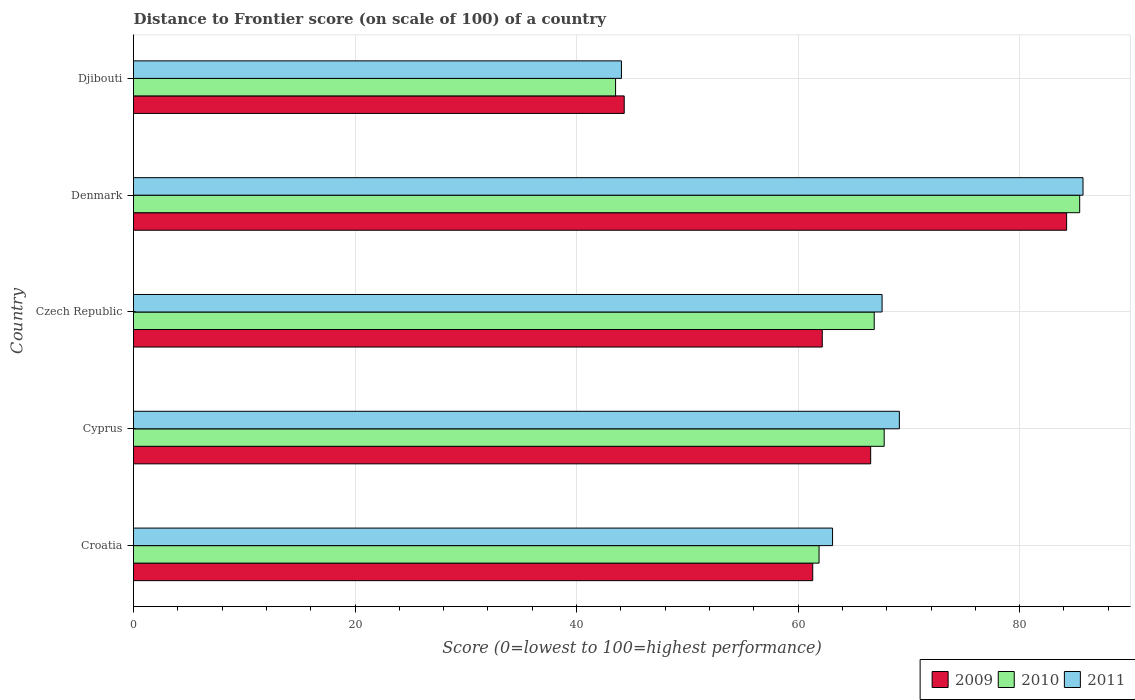How many different coloured bars are there?
Provide a short and direct response. 3. Are the number of bars on each tick of the Y-axis equal?
Your answer should be very brief. Yes. How many bars are there on the 5th tick from the top?
Offer a very short reply. 3. How many bars are there on the 1st tick from the bottom?
Give a very brief answer. 3. What is the label of the 3rd group of bars from the top?
Your response must be concise. Czech Republic. In how many cases, is the number of bars for a given country not equal to the number of legend labels?
Your answer should be compact. 0. What is the distance to frontier score of in 2010 in Czech Republic?
Your answer should be very brief. 66.87. Across all countries, what is the maximum distance to frontier score of in 2011?
Your answer should be compact. 85.72. Across all countries, what is the minimum distance to frontier score of in 2011?
Your answer should be very brief. 44.05. In which country was the distance to frontier score of in 2011 minimum?
Offer a very short reply. Djibouti. What is the total distance to frontier score of in 2011 in the graph?
Your answer should be compact. 329.6. What is the difference between the distance to frontier score of in 2009 in Croatia and that in Denmark?
Keep it short and to the point. -22.92. What is the difference between the distance to frontier score of in 2010 in Djibouti and the distance to frontier score of in 2009 in Cyprus?
Your answer should be compact. -23.03. What is the average distance to frontier score of in 2009 per country?
Offer a very short reply. 63.72. What is the difference between the distance to frontier score of in 2010 and distance to frontier score of in 2009 in Denmark?
Provide a succinct answer. 1.18. In how many countries, is the distance to frontier score of in 2010 greater than 84 ?
Make the answer very short. 1. What is the ratio of the distance to frontier score of in 2009 in Croatia to that in Djibouti?
Ensure brevity in your answer.  1.38. Is the difference between the distance to frontier score of in 2010 in Czech Republic and Djibouti greater than the difference between the distance to frontier score of in 2009 in Czech Republic and Djibouti?
Provide a short and direct response. Yes. What is the difference between the highest and the second highest distance to frontier score of in 2009?
Provide a short and direct response. 17.69. What is the difference between the highest and the lowest distance to frontier score of in 2009?
Give a very brief answer. 39.94. In how many countries, is the distance to frontier score of in 2010 greater than the average distance to frontier score of in 2010 taken over all countries?
Keep it short and to the point. 3. Is the sum of the distance to frontier score of in 2010 in Cyprus and Djibouti greater than the maximum distance to frontier score of in 2011 across all countries?
Your answer should be very brief. Yes. How many bars are there?
Your answer should be very brief. 15. Are all the bars in the graph horizontal?
Make the answer very short. Yes. Are the values on the major ticks of X-axis written in scientific E-notation?
Your response must be concise. No. Does the graph contain grids?
Your response must be concise. Yes. How are the legend labels stacked?
Offer a very short reply. Horizontal. What is the title of the graph?
Your answer should be compact. Distance to Frontier score (on scale of 100) of a country. What is the label or title of the X-axis?
Provide a succinct answer. Score (0=lowest to 100=highest performance). What is the Score (0=lowest to 100=highest performance) in 2009 in Croatia?
Make the answer very short. 61.32. What is the Score (0=lowest to 100=highest performance) in 2010 in Croatia?
Provide a succinct answer. 61.89. What is the Score (0=lowest to 100=highest performance) in 2011 in Croatia?
Provide a short and direct response. 63.11. What is the Score (0=lowest to 100=highest performance) in 2009 in Cyprus?
Your response must be concise. 66.55. What is the Score (0=lowest to 100=highest performance) of 2010 in Cyprus?
Provide a succinct answer. 67.77. What is the Score (0=lowest to 100=highest performance) of 2011 in Cyprus?
Keep it short and to the point. 69.14. What is the Score (0=lowest to 100=highest performance) in 2009 in Czech Republic?
Your response must be concise. 62.18. What is the Score (0=lowest to 100=highest performance) in 2010 in Czech Republic?
Keep it short and to the point. 66.87. What is the Score (0=lowest to 100=highest performance) of 2011 in Czech Republic?
Your answer should be compact. 67.58. What is the Score (0=lowest to 100=highest performance) of 2009 in Denmark?
Offer a very short reply. 84.24. What is the Score (0=lowest to 100=highest performance) in 2010 in Denmark?
Your response must be concise. 85.42. What is the Score (0=lowest to 100=highest performance) in 2011 in Denmark?
Keep it short and to the point. 85.72. What is the Score (0=lowest to 100=highest performance) in 2009 in Djibouti?
Provide a succinct answer. 44.3. What is the Score (0=lowest to 100=highest performance) in 2010 in Djibouti?
Your answer should be very brief. 43.52. What is the Score (0=lowest to 100=highest performance) of 2011 in Djibouti?
Make the answer very short. 44.05. Across all countries, what is the maximum Score (0=lowest to 100=highest performance) of 2009?
Your answer should be compact. 84.24. Across all countries, what is the maximum Score (0=lowest to 100=highest performance) of 2010?
Offer a terse response. 85.42. Across all countries, what is the maximum Score (0=lowest to 100=highest performance) of 2011?
Ensure brevity in your answer.  85.72. Across all countries, what is the minimum Score (0=lowest to 100=highest performance) in 2009?
Your response must be concise. 44.3. Across all countries, what is the minimum Score (0=lowest to 100=highest performance) in 2010?
Provide a succinct answer. 43.52. Across all countries, what is the minimum Score (0=lowest to 100=highest performance) in 2011?
Ensure brevity in your answer.  44.05. What is the total Score (0=lowest to 100=highest performance) of 2009 in the graph?
Keep it short and to the point. 318.59. What is the total Score (0=lowest to 100=highest performance) in 2010 in the graph?
Your response must be concise. 325.47. What is the total Score (0=lowest to 100=highest performance) of 2011 in the graph?
Provide a succinct answer. 329.6. What is the difference between the Score (0=lowest to 100=highest performance) of 2009 in Croatia and that in Cyprus?
Provide a short and direct response. -5.23. What is the difference between the Score (0=lowest to 100=highest performance) of 2010 in Croatia and that in Cyprus?
Your response must be concise. -5.88. What is the difference between the Score (0=lowest to 100=highest performance) of 2011 in Croatia and that in Cyprus?
Your response must be concise. -6.03. What is the difference between the Score (0=lowest to 100=highest performance) in 2009 in Croatia and that in Czech Republic?
Give a very brief answer. -0.86. What is the difference between the Score (0=lowest to 100=highest performance) of 2010 in Croatia and that in Czech Republic?
Make the answer very short. -4.98. What is the difference between the Score (0=lowest to 100=highest performance) in 2011 in Croatia and that in Czech Republic?
Give a very brief answer. -4.47. What is the difference between the Score (0=lowest to 100=highest performance) in 2009 in Croatia and that in Denmark?
Keep it short and to the point. -22.92. What is the difference between the Score (0=lowest to 100=highest performance) of 2010 in Croatia and that in Denmark?
Make the answer very short. -23.53. What is the difference between the Score (0=lowest to 100=highest performance) in 2011 in Croatia and that in Denmark?
Make the answer very short. -22.61. What is the difference between the Score (0=lowest to 100=highest performance) of 2009 in Croatia and that in Djibouti?
Offer a terse response. 17.02. What is the difference between the Score (0=lowest to 100=highest performance) of 2010 in Croatia and that in Djibouti?
Give a very brief answer. 18.37. What is the difference between the Score (0=lowest to 100=highest performance) in 2011 in Croatia and that in Djibouti?
Your answer should be compact. 19.06. What is the difference between the Score (0=lowest to 100=highest performance) in 2009 in Cyprus and that in Czech Republic?
Keep it short and to the point. 4.37. What is the difference between the Score (0=lowest to 100=highest performance) in 2010 in Cyprus and that in Czech Republic?
Your response must be concise. 0.9. What is the difference between the Score (0=lowest to 100=highest performance) of 2011 in Cyprus and that in Czech Republic?
Make the answer very short. 1.56. What is the difference between the Score (0=lowest to 100=highest performance) of 2009 in Cyprus and that in Denmark?
Ensure brevity in your answer.  -17.69. What is the difference between the Score (0=lowest to 100=highest performance) of 2010 in Cyprus and that in Denmark?
Offer a very short reply. -17.65. What is the difference between the Score (0=lowest to 100=highest performance) of 2011 in Cyprus and that in Denmark?
Keep it short and to the point. -16.58. What is the difference between the Score (0=lowest to 100=highest performance) of 2009 in Cyprus and that in Djibouti?
Your answer should be compact. 22.25. What is the difference between the Score (0=lowest to 100=highest performance) of 2010 in Cyprus and that in Djibouti?
Provide a short and direct response. 24.25. What is the difference between the Score (0=lowest to 100=highest performance) of 2011 in Cyprus and that in Djibouti?
Ensure brevity in your answer.  25.09. What is the difference between the Score (0=lowest to 100=highest performance) in 2009 in Czech Republic and that in Denmark?
Your answer should be compact. -22.06. What is the difference between the Score (0=lowest to 100=highest performance) of 2010 in Czech Republic and that in Denmark?
Keep it short and to the point. -18.55. What is the difference between the Score (0=lowest to 100=highest performance) in 2011 in Czech Republic and that in Denmark?
Keep it short and to the point. -18.14. What is the difference between the Score (0=lowest to 100=highest performance) of 2009 in Czech Republic and that in Djibouti?
Your answer should be very brief. 17.88. What is the difference between the Score (0=lowest to 100=highest performance) in 2010 in Czech Republic and that in Djibouti?
Provide a succinct answer. 23.35. What is the difference between the Score (0=lowest to 100=highest performance) in 2011 in Czech Republic and that in Djibouti?
Your answer should be compact. 23.53. What is the difference between the Score (0=lowest to 100=highest performance) of 2009 in Denmark and that in Djibouti?
Provide a short and direct response. 39.94. What is the difference between the Score (0=lowest to 100=highest performance) of 2010 in Denmark and that in Djibouti?
Offer a very short reply. 41.9. What is the difference between the Score (0=lowest to 100=highest performance) in 2011 in Denmark and that in Djibouti?
Provide a succinct answer. 41.67. What is the difference between the Score (0=lowest to 100=highest performance) in 2009 in Croatia and the Score (0=lowest to 100=highest performance) in 2010 in Cyprus?
Offer a terse response. -6.45. What is the difference between the Score (0=lowest to 100=highest performance) of 2009 in Croatia and the Score (0=lowest to 100=highest performance) of 2011 in Cyprus?
Give a very brief answer. -7.82. What is the difference between the Score (0=lowest to 100=highest performance) in 2010 in Croatia and the Score (0=lowest to 100=highest performance) in 2011 in Cyprus?
Give a very brief answer. -7.25. What is the difference between the Score (0=lowest to 100=highest performance) in 2009 in Croatia and the Score (0=lowest to 100=highest performance) in 2010 in Czech Republic?
Provide a succinct answer. -5.55. What is the difference between the Score (0=lowest to 100=highest performance) in 2009 in Croatia and the Score (0=lowest to 100=highest performance) in 2011 in Czech Republic?
Your answer should be compact. -6.26. What is the difference between the Score (0=lowest to 100=highest performance) in 2010 in Croatia and the Score (0=lowest to 100=highest performance) in 2011 in Czech Republic?
Provide a short and direct response. -5.69. What is the difference between the Score (0=lowest to 100=highest performance) in 2009 in Croatia and the Score (0=lowest to 100=highest performance) in 2010 in Denmark?
Keep it short and to the point. -24.1. What is the difference between the Score (0=lowest to 100=highest performance) of 2009 in Croatia and the Score (0=lowest to 100=highest performance) of 2011 in Denmark?
Offer a terse response. -24.4. What is the difference between the Score (0=lowest to 100=highest performance) in 2010 in Croatia and the Score (0=lowest to 100=highest performance) in 2011 in Denmark?
Your answer should be compact. -23.83. What is the difference between the Score (0=lowest to 100=highest performance) in 2009 in Croatia and the Score (0=lowest to 100=highest performance) in 2011 in Djibouti?
Provide a short and direct response. 17.27. What is the difference between the Score (0=lowest to 100=highest performance) in 2010 in Croatia and the Score (0=lowest to 100=highest performance) in 2011 in Djibouti?
Provide a succinct answer. 17.84. What is the difference between the Score (0=lowest to 100=highest performance) of 2009 in Cyprus and the Score (0=lowest to 100=highest performance) of 2010 in Czech Republic?
Provide a succinct answer. -0.32. What is the difference between the Score (0=lowest to 100=highest performance) of 2009 in Cyprus and the Score (0=lowest to 100=highest performance) of 2011 in Czech Republic?
Offer a terse response. -1.03. What is the difference between the Score (0=lowest to 100=highest performance) in 2010 in Cyprus and the Score (0=lowest to 100=highest performance) in 2011 in Czech Republic?
Keep it short and to the point. 0.19. What is the difference between the Score (0=lowest to 100=highest performance) of 2009 in Cyprus and the Score (0=lowest to 100=highest performance) of 2010 in Denmark?
Keep it short and to the point. -18.87. What is the difference between the Score (0=lowest to 100=highest performance) in 2009 in Cyprus and the Score (0=lowest to 100=highest performance) in 2011 in Denmark?
Make the answer very short. -19.17. What is the difference between the Score (0=lowest to 100=highest performance) of 2010 in Cyprus and the Score (0=lowest to 100=highest performance) of 2011 in Denmark?
Your answer should be very brief. -17.95. What is the difference between the Score (0=lowest to 100=highest performance) of 2009 in Cyprus and the Score (0=lowest to 100=highest performance) of 2010 in Djibouti?
Give a very brief answer. 23.03. What is the difference between the Score (0=lowest to 100=highest performance) in 2010 in Cyprus and the Score (0=lowest to 100=highest performance) in 2011 in Djibouti?
Keep it short and to the point. 23.72. What is the difference between the Score (0=lowest to 100=highest performance) in 2009 in Czech Republic and the Score (0=lowest to 100=highest performance) in 2010 in Denmark?
Your answer should be compact. -23.24. What is the difference between the Score (0=lowest to 100=highest performance) of 2009 in Czech Republic and the Score (0=lowest to 100=highest performance) of 2011 in Denmark?
Provide a succinct answer. -23.54. What is the difference between the Score (0=lowest to 100=highest performance) of 2010 in Czech Republic and the Score (0=lowest to 100=highest performance) of 2011 in Denmark?
Keep it short and to the point. -18.85. What is the difference between the Score (0=lowest to 100=highest performance) of 2009 in Czech Republic and the Score (0=lowest to 100=highest performance) of 2010 in Djibouti?
Provide a short and direct response. 18.66. What is the difference between the Score (0=lowest to 100=highest performance) of 2009 in Czech Republic and the Score (0=lowest to 100=highest performance) of 2011 in Djibouti?
Provide a succinct answer. 18.13. What is the difference between the Score (0=lowest to 100=highest performance) of 2010 in Czech Republic and the Score (0=lowest to 100=highest performance) of 2011 in Djibouti?
Offer a very short reply. 22.82. What is the difference between the Score (0=lowest to 100=highest performance) of 2009 in Denmark and the Score (0=lowest to 100=highest performance) of 2010 in Djibouti?
Keep it short and to the point. 40.72. What is the difference between the Score (0=lowest to 100=highest performance) of 2009 in Denmark and the Score (0=lowest to 100=highest performance) of 2011 in Djibouti?
Give a very brief answer. 40.19. What is the difference between the Score (0=lowest to 100=highest performance) of 2010 in Denmark and the Score (0=lowest to 100=highest performance) of 2011 in Djibouti?
Provide a succinct answer. 41.37. What is the average Score (0=lowest to 100=highest performance) of 2009 per country?
Provide a short and direct response. 63.72. What is the average Score (0=lowest to 100=highest performance) of 2010 per country?
Your response must be concise. 65.09. What is the average Score (0=lowest to 100=highest performance) of 2011 per country?
Offer a very short reply. 65.92. What is the difference between the Score (0=lowest to 100=highest performance) of 2009 and Score (0=lowest to 100=highest performance) of 2010 in Croatia?
Provide a succinct answer. -0.57. What is the difference between the Score (0=lowest to 100=highest performance) of 2009 and Score (0=lowest to 100=highest performance) of 2011 in Croatia?
Your answer should be compact. -1.79. What is the difference between the Score (0=lowest to 100=highest performance) in 2010 and Score (0=lowest to 100=highest performance) in 2011 in Croatia?
Provide a succinct answer. -1.22. What is the difference between the Score (0=lowest to 100=highest performance) in 2009 and Score (0=lowest to 100=highest performance) in 2010 in Cyprus?
Your answer should be very brief. -1.22. What is the difference between the Score (0=lowest to 100=highest performance) in 2009 and Score (0=lowest to 100=highest performance) in 2011 in Cyprus?
Provide a short and direct response. -2.59. What is the difference between the Score (0=lowest to 100=highest performance) in 2010 and Score (0=lowest to 100=highest performance) in 2011 in Cyprus?
Provide a short and direct response. -1.37. What is the difference between the Score (0=lowest to 100=highest performance) of 2009 and Score (0=lowest to 100=highest performance) of 2010 in Czech Republic?
Offer a very short reply. -4.69. What is the difference between the Score (0=lowest to 100=highest performance) of 2010 and Score (0=lowest to 100=highest performance) of 2011 in Czech Republic?
Your answer should be compact. -0.71. What is the difference between the Score (0=lowest to 100=highest performance) in 2009 and Score (0=lowest to 100=highest performance) in 2010 in Denmark?
Give a very brief answer. -1.18. What is the difference between the Score (0=lowest to 100=highest performance) in 2009 and Score (0=lowest to 100=highest performance) in 2011 in Denmark?
Ensure brevity in your answer.  -1.48. What is the difference between the Score (0=lowest to 100=highest performance) in 2010 and Score (0=lowest to 100=highest performance) in 2011 in Denmark?
Your answer should be compact. -0.3. What is the difference between the Score (0=lowest to 100=highest performance) of 2009 and Score (0=lowest to 100=highest performance) of 2010 in Djibouti?
Give a very brief answer. 0.78. What is the difference between the Score (0=lowest to 100=highest performance) of 2010 and Score (0=lowest to 100=highest performance) of 2011 in Djibouti?
Give a very brief answer. -0.53. What is the ratio of the Score (0=lowest to 100=highest performance) of 2009 in Croatia to that in Cyprus?
Your answer should be compact. 0.92. What is the ratio of the Score (0=lowest to 100=highest performance) of 2010 in Croatia to that in Cyprus?
Make the answer very short. 0.91. What is the ratio of the Score (0=lowest to 100=highest performance) in 2011 in Croatia to that in Cyprus?
Offer a terse response. 0.91. What is the ratio of the Score (0=lowest to 100=highest performance) in 2009 in Croatia to that in Czech Republic?
Keep it short and to the point. 0.99. What is the ratio of the Score (0=lowest to 100=highest performance) of 2010 in Croatia to that in Czech Republic?
Give a very brief answer. 0.93. What is the ratio of the Score (0=lowest to 100=highest performance) in 2011 in Croatia to that in Czech Republic?
Keep it short and to the point. 0.93. What is the ratio of the Score (0=lowest to 100=highest performance) of 2009 in Croatia to that in Denmark?
Provide a short and direct response. 0.73. What is the ratio of the Score (0=lowest to 100=highest performance) in 2010 in Croatia to that in Denmark?
Your answer should be very brief. 0.72. What is the ratio of the Score (0=lowest to 100=highest performance) of 2011 in Croatia to that in Denmark?
Provide a succinct answer. 0.74. What is the ratio of the Score (0=lowest to 100=highest performance) in 2009 in Croatia to that in Djibouti?
Provide a succinct answer. 1.38. What is the ratio of the Score (0=lowest to 100=highest performance) in 2010 in Croatia to that in Djibouti?
Offer a terse response. 1.42. What is the ratio of the Score (0=lowest to 100=highest performance) in 2011 in Croatia to that in Djibouti?
Your response must be concise. 1.43. What is the ratio of the Score (0=lowest to 100=highest performance) of 2009 in Cyprus to that in Czech Republic?
Your response must be concise. 1.07. What is the ratio of the Score (0=lowest to 100=highest performance) of 2010 in Cyprus to that in Czech Republic?
Offer a terse response. 1.01. What is the ratio of the Score (0=lowest to 100=highest performance) of 2011 in Cyprus to that in Czech Republic?
Keep it short and to the point. 1.02. What is the ratio of the Score (0=lowest to 100=highest performance) of 2009 in Cyprus to that in Denmark?
Ensure brevity in your answer.  0.79. What is the ratio of the Score (0=lowest to 100=highest performance) of 2010 in Cyprus to that in Denmark?
Offer a very short reply. 0.79. What is the ratio of the Score (0=lowest to 100=highest performance) of 2011 in Cyprus to that in Denmark?
Keep it short and to the point. 0.81. What is the ratio of the Score (0=lowest to 100=highest performance) in 2009 in Cyprus to that in Djibouti?
Provide a short and direct response. 1.5. What is the ratio of the Score (0=lowest to 100=highest performance) of 2010 in Cyprus to that in Djibouti?
Provide a succinct answer. 1.56. What is the ratio of the Score (0=lowest to 100=highest performance) of 2011 in Cyprus to that in Djibouti?
Make the answer very short. 1.57. What is the ratio of the Score (0=lowest to 100=highest performance) of 2009 in Czech Republic to that in Denmark?
Give a very brief answer. 0.74. What is the ratio of the Score (0=lowest to 100=highest performance) of 2010 in Czech Republic to that in Denmark?
Make the answer very short. 0.78. What is the ratio of the Score (0=lowest to 100=highest performance) of 2011 in Czech Republic to that in Denmark?
Ensure brevity in your answer.  0.79. What is the ratio of the Score (0=lowest to 100=highest performance) of 2009 in Czech Republic to that in Djibouti?
Offer a very short reply. 1.4. What is the ratio of the Score (0=lowest to 100=highest performance) of 2010 in Czech Republic to that in Djibouti?
Offer a very short reply. 1.54. What is the ratio of the Score (0=lowest to 100=highest performance) in 2011 in Czech Republic to that in Djibouti?
Ensure brevity in your answer.  1.53. What is the ratio of the Score (0=lowest to 100=highest performance) of 2009 in Denmark to that in Djibouti?
Ensure brevity in your answer.  1.9. What is the ratio of the Score (0=lowest to 100=highest performance) in 2010 in Denmark to that in Djibouti?
Make the answer very short. 1.96. What is the ratio of the Score (0=lowest to 100=highest performance) in 2011 in Denmark to that in Djibouti?
Provide a succinct answer. 1.95. What is the difference between the highest and the second highest Score (0=lowest to 100=highest performance) in 2009?
Make the answer very short. 17.69. What is the difference between the highest and the second highest Score (0=lowest to 100=highest performance) in 2010?
Your answer should be very brief. 17.65. What is the difference between the highest and the second highest Score (0=lowest to 100=highest performance) of 2011?
Keep it short and to the point. 16.58. What is the difference between the highest and the lowest Score (0=lowest to 100=highest performance) of 2009?
Give a very brief answer. 39.94. What is the difference between the highest and the lowest Score (0=lowest to 100=highest performance) in 2010?
Provide a short and direct response. 41.9. What is the difference between the highest and the lowest Score (0=lowest to 100=highest performance) in 2011?
Offer a terse response. 41.67. 